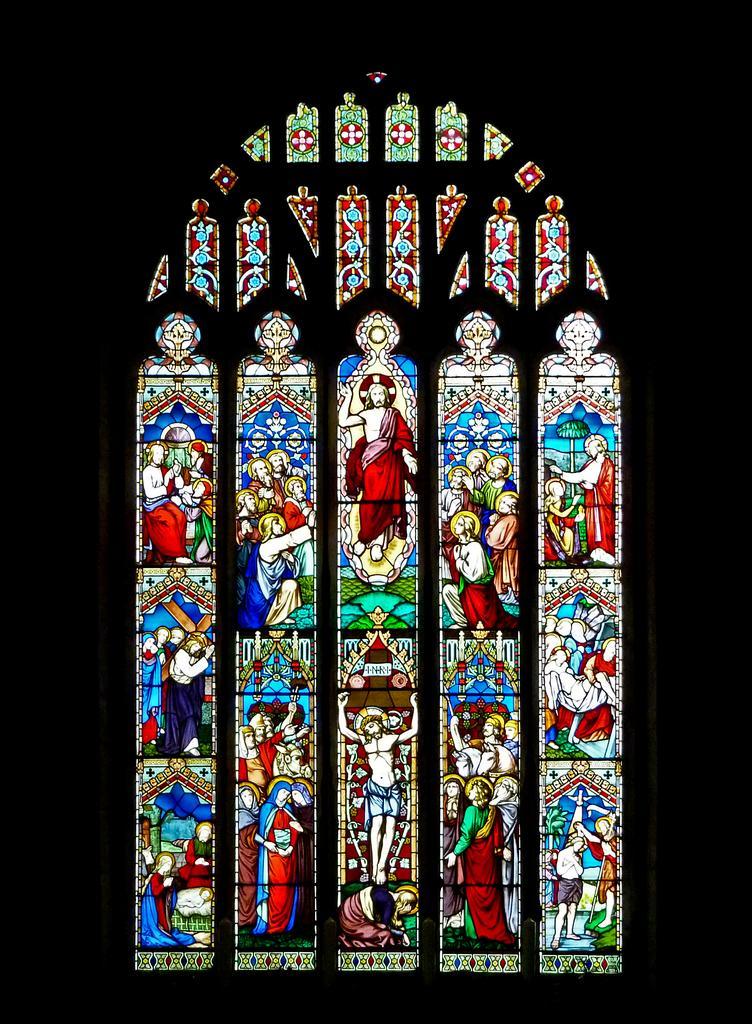Could you give a brief overview of what you see in this image? In this image I can see a wall and wall paintings. This image is taken may be in a church. 